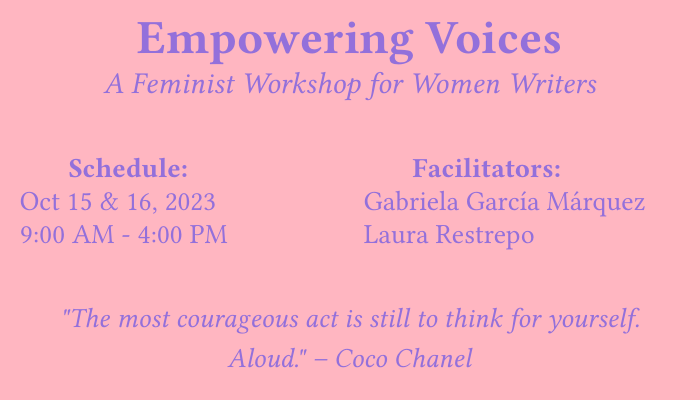What is the name of the workshop? The name of the workshop is presented in a prominent title on the card.
Answer: Empowering Voices Who are the facilitators? The facilitators' names are listed in the designated section of the card.
Answer: Gabriela García Márquez, Laura Restrepo What are the dates of the workshop? The dates for the workshop are stated in the schedule section of the card.
Answer: Oct 15 & 16, 2023 What time does the workshop start? The start time of the workshop is mentioned in the schedule section.
Answer: 9:00 AM Is there a registration fee for participants? The document specifies the registration details, including any fees.
Answer: Free for all participants What is the contact email for the workshop? The contact email is provided in the communication section of the card.
Answer: info@empoweringvoicesworkshop.com What color is the background of the card? The background color is specified at the beginning of the document.
Answer: Soft pink What quote is included in the card? The quote is prominently displayed within the design.
Answer: "The most courageous act is still to think for yourself. Aloud." – Coco Chanel Where can one register for the workshop? The website for registration is provided on the card.
Answer: www.empoweringvoicesworkshop.com/register 